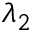<formula> <loc_0><loc_0><loc_500><loc_500>\lambda _ { 2 }</formula> 